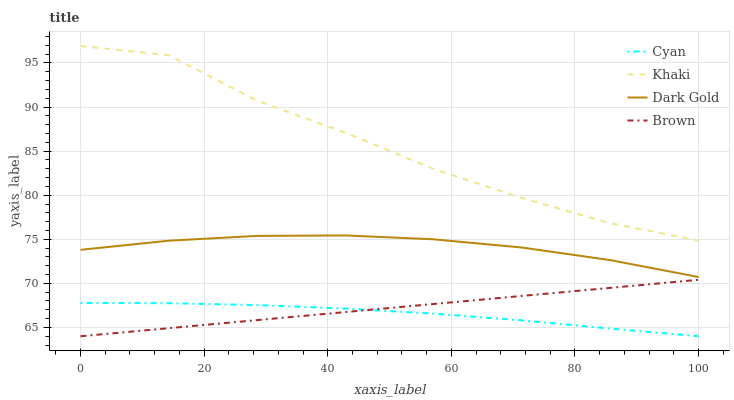Does Cyan have the minimum area under the curve?
Answer yes or no. Yes. Does Khaki have the maximum area under the curve?
Answer yes or no. Yes. Does Brown have the minimum area under the curve?
Answer yes or no. No. Does Brown have the maximum area under the curve?
Answer yes or no. No. Is Brown the smoothest?
Answer yes or no. Yes. Is Khaki the roughest?
Answer yes or no. Yes. Is Khaki the smoothest?
Answer yes or no. No. Is Brown the roughest?
Answer yes or no. No. Does Cyan have the lowest value?
Answer yes or no. Yes. Does Khaki have the lowest value?
Answer yes or no. No. Does Khaki have the highest value?
Answer yes or no. Yes. Does Brown have the highest value?
Answer yes or no. No. Is Cyan less than Dark Gold?
Answer yes or no. Yes. Is Dark Gold greater than Cyan?
Answer yes or no. Yes. Does Brown intersect Cyan?
Answer yes or no. Yes. Is Brown less than Cyan?
Answer yes or no. No. Is Brown greater than Cyan?
Answer yes or no. No. Does Cyan intersect Dark Gold?
Answer yes or no. No. 